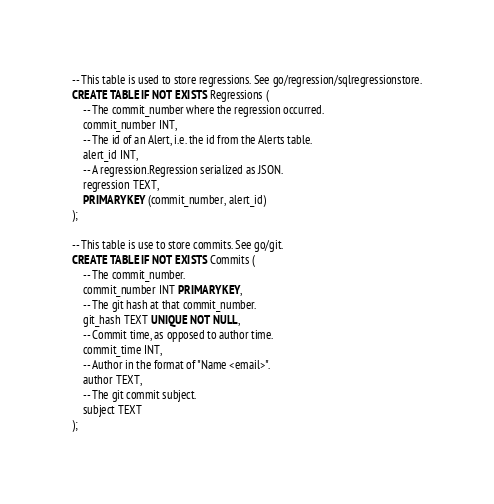Convert code to text. <code><loc_0><loc_0><loc_500><loc_500><_SQL_>-- This table is used to store regressions. See go/regression/sqlregressionstore.
CREATE TABLE IF NOT EXISTS Regressions (
	-- The commit_number where the regression occurred.
	commit_number INT,
	-- The id of an Alert, i.e. the id from the Alerts table.
	alert_id INT,
	-- A regression.Regression serialized as JSON.
	regression TEXT,
	PRIMARY KEY (commit_number, alert_id)
);

-- This table is use to store commits. See go/git.
CREATE TABLE IF NOT EXISTS Commits (
	-- The commit_number.
	commit_number INT PRIMARY KEY,
	-- The git hash at that commit_number.
	git_hash TEXT UNIQUE NOT NULL,
	-- Commit time, as opposed to author time.
	commit_time INT,
	-- Author in the format of "Name <email>".
	author TEXT,
	-- The git commit subject.
	subject TEXT
);</code> 